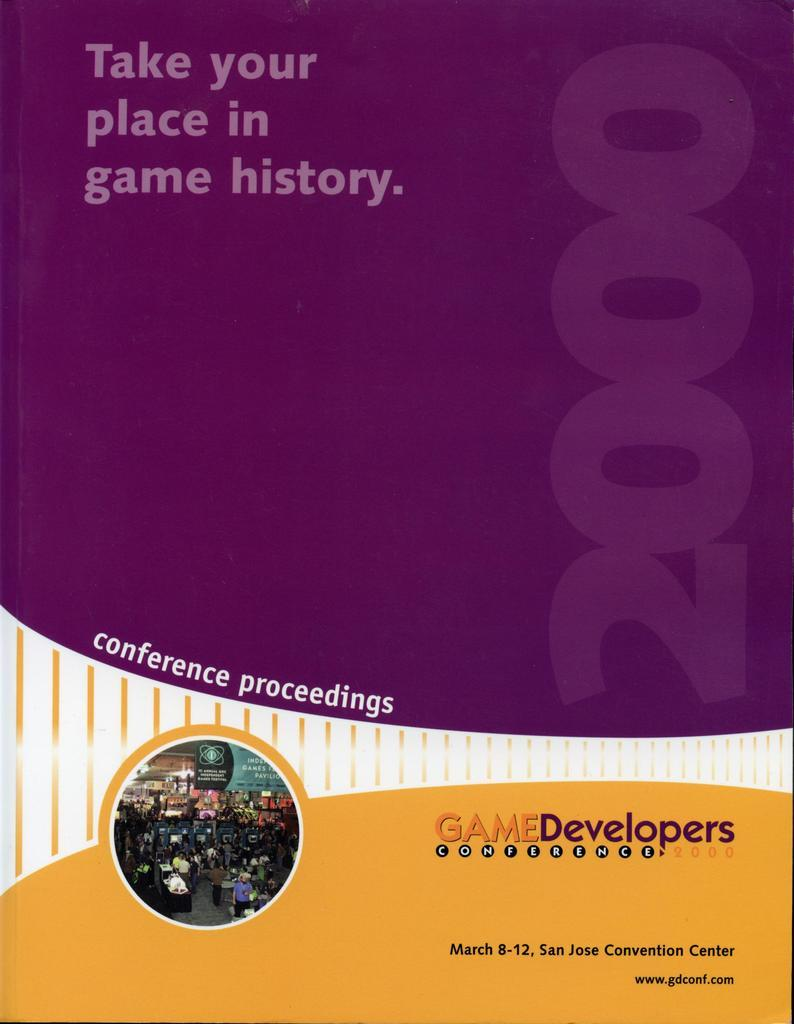<image>
Describe the image concisely. a purple and yellow notebook that has Game Developers written on it 